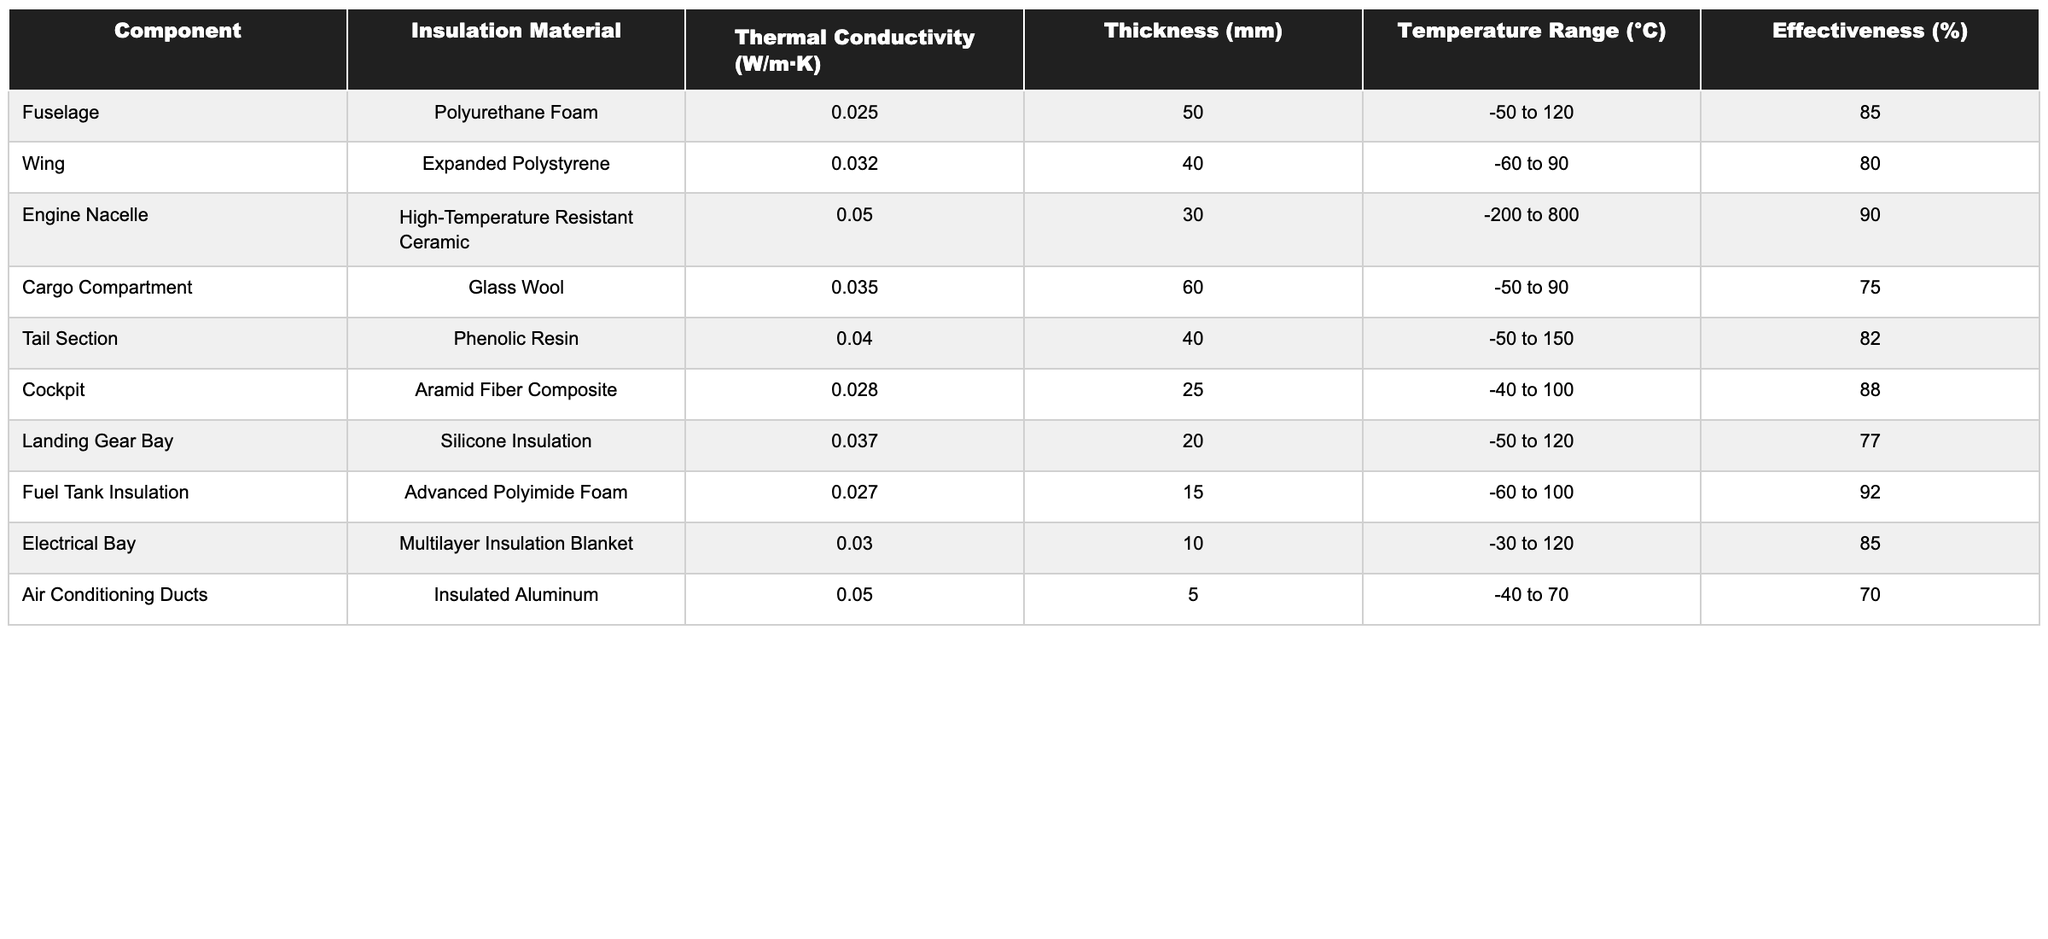What is the thermal conductivity of the Engine Nacelle insulation material? The table shows that the thermal conductivity for the Engine Nacelle, which uses High-Temperature Resistant Ceramic, is listed as 0.05 W/m·K.
Answer: 0.05 W/m·K Which component has the highest effectiveness percentage? By comparing the effectiveness percentages across all components in the table, the Engine Nacelle has the highest effectiveness at 90%.
Answer: Engine Nacelle What is the thickness of the Fuel Tank Insulation? The table indicates that the thickness of the Fuel Tank Insulation, made of Advanced Polyimide Foam, is 15 mm.
Answer: 15 mm Is the effectiveness of the Tail Section insulation greater than 80%? The table lists the effectiveness of the Tail Section as 82%, which is indeed greater than 80%.
Answer: Yes What is the average effectiveness percentage of the cockpit and electrical bay? The effectiveness of the Cockpit is 88% and the Electrical Bay is 85%. The average is calculated as (88 + 85) / 2 = 86.5%.
Answer: 86.5% Which two insulation materials have the lowest thermal conductivity? Reviewing the thermal conductivity values, Polyurethane Foam (0.025 W/m·K) and Advanced Polyimide Foam (0.027 W/m·K) have the lowest.
Answer: Polyurethane Foam and Advanced Polyimide Foam What is the difference in effectiveness between the Wing and the Cargo Compartment? The effectiveness of the Wing is 80% and the Cargo Compartment is 75%. The difference is calculated as 80% - 75% = 5%.
Answer: 5% Which component has the lowest temperature range, and what is that range? Looking at the temperature ranges, the Air Conditioning Ducts has the lowest range of -40 to 70 °C.
Answer: -40 to 70 °C In terms of insulation materials, how many components use foam-based materials? The components using foam-based materials are the Fuselage (Polyurethane Foam), Fuel Tank Insulation (Advanced Polyimide Foam), making a total of 2 components.
Answer: 2 components If you were to rank all components based on their effectiveness, what would be the rank of the Landing Gear Bay? The effectiveness of the Landing Gear Bay is 77%. Upon ranking all components from highest to lowest effectiveness, Landing Gear Bay comes in 7th.
Answer: 7th 